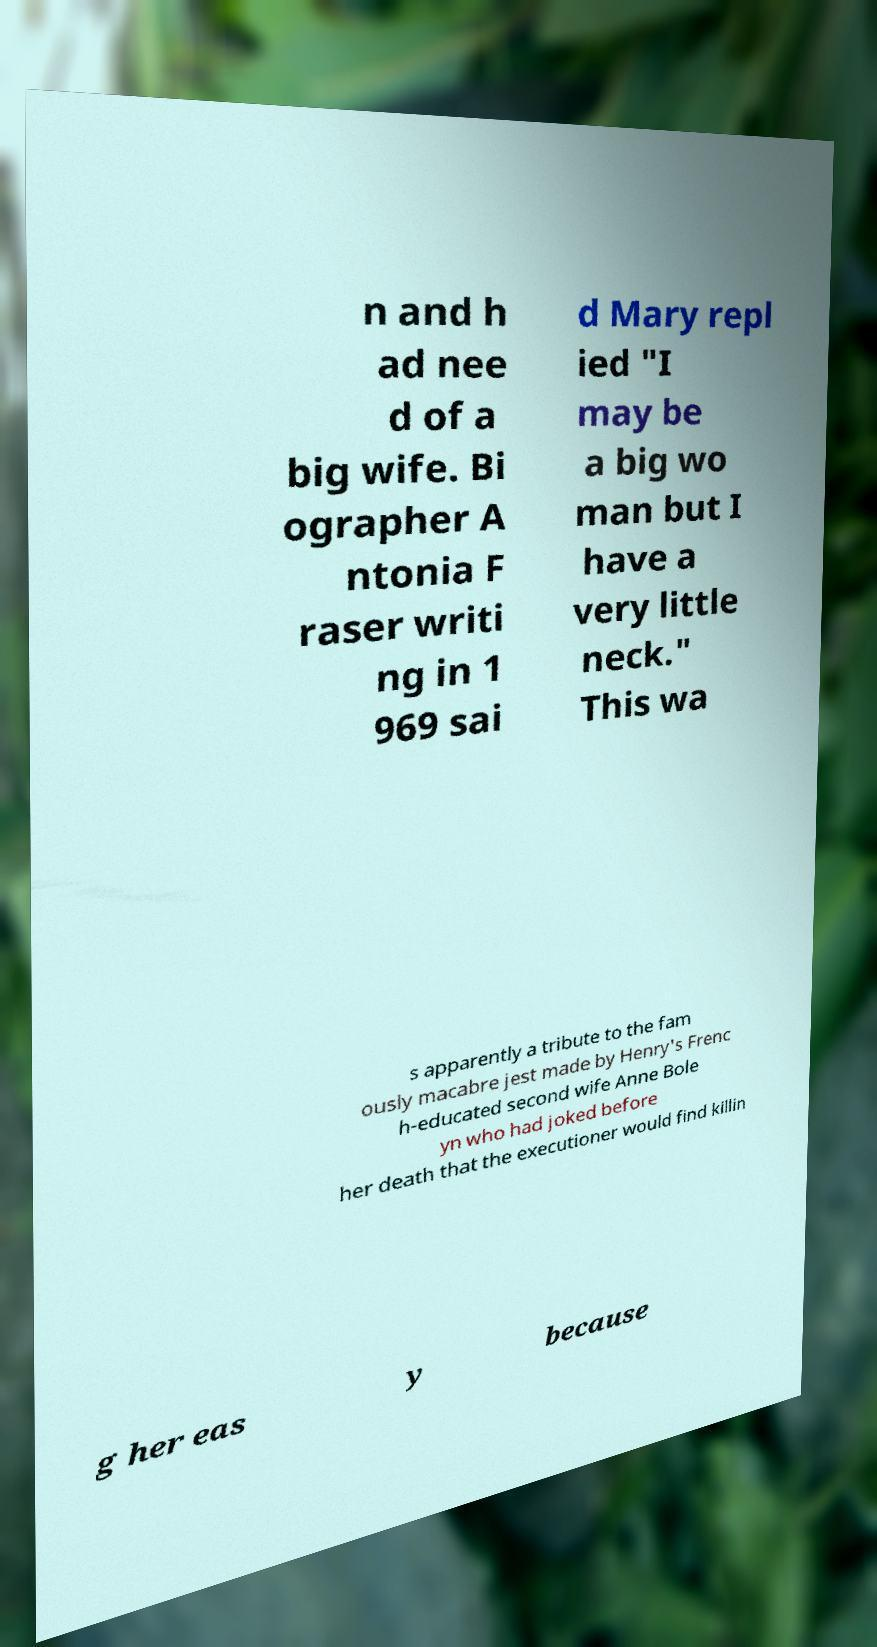Could you extract and type out the text from this image? n and h ad nee d of a big wife. Bi ographer A ntonia F raser writi ng in 1 969 sai d Mary repl ied "I may be a big wo man but I have a very little neck." This wa s apparently a tribute to the fam ously macabre jest made by Henry's Frenc h-educated second wife Anne Bole yn who had joked before her death that the executioner would find killin g her eas y because 